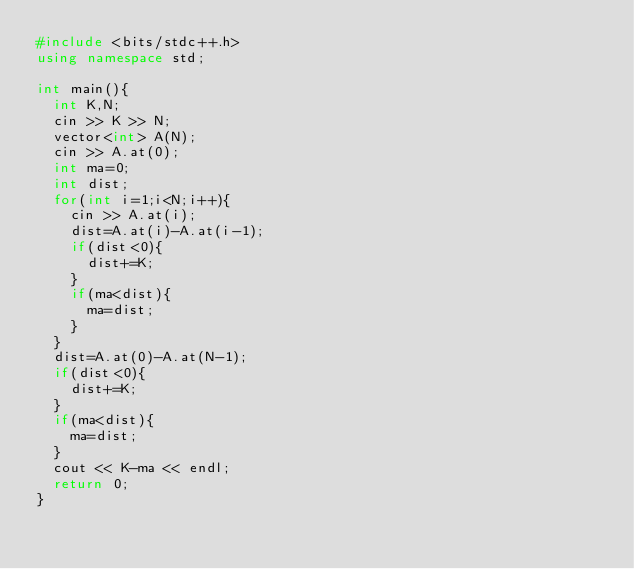<code> <loc_0><loc_0><loc_500><loc_500><_C++_>#include <bits/stdc++.h>
using namespace std;

int main(){
  int K,N;
  cin >> K >> N;
  vector<int> A(N);
  cin >> A.at(0);
  int ma=0;
  int dist;
  for(int i=1;i<N;i++){
    cin >> A.at(i);
    dist=A.at(i)-A.at(i-1);
    if(dist<0){
      dist+=K;
    }
    if(ma<dist){
      ma=dist;
    }
  }
  dist=A.at(0)-A.at(N-1);
  if(dist<0){
    dist+=K;
  }
  if(ma<dist){
    ma=dist;
  }
  cout << K-ma << endl;
  return 0;
}
</code> 